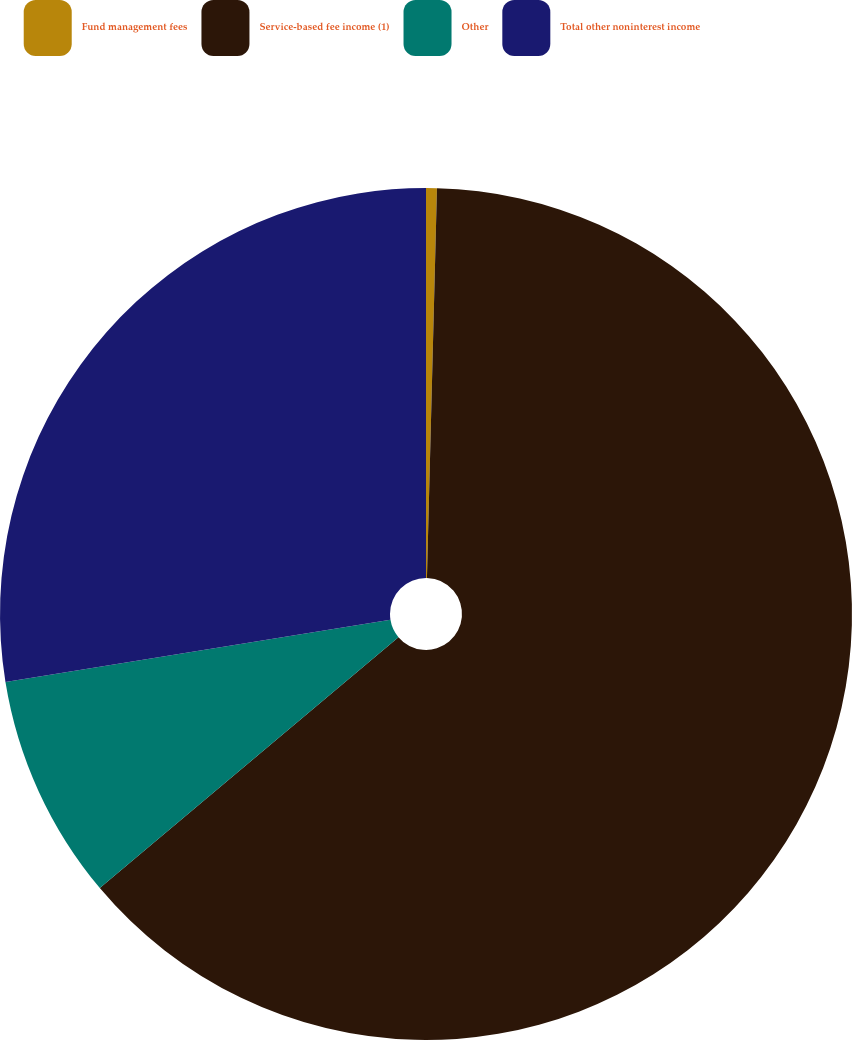Convert chart to OTSL. <chart><loc_0><loc_0><loc_500><loc_500><pie_chart><fcel>Fund management fees<fcel>Service-based fee income (1)<fcel>Other<fcel>Total other noninterest income<nl><fcel>0.41%<fcel>63.47%<fcel>8.57%<fcel>27.55%<nl></chart> 